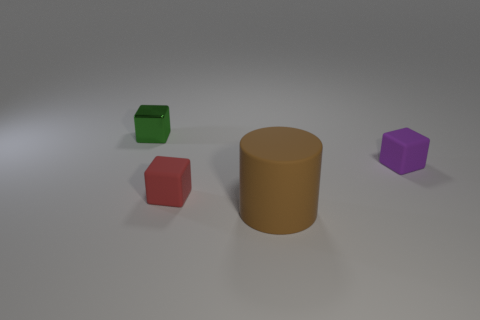Add 3 large cylinders. How many objects exist? 7 Subtract all gray blocks. Subtract all green spheres. How many blocks are left? 3 Subtract all blocks. How many objects are left? 1 Subtract all large yellow matte spheres. Subtract all purple rubber objects. How many objects are left? 3 Add 1 tiny red rubber cubes. How many tiny red rubber cubes are left? 2 Add 2 red matte cubes. How many red matte cubes exist? 3 Subtract 0 cyan cubes. How many objects are left? 4 